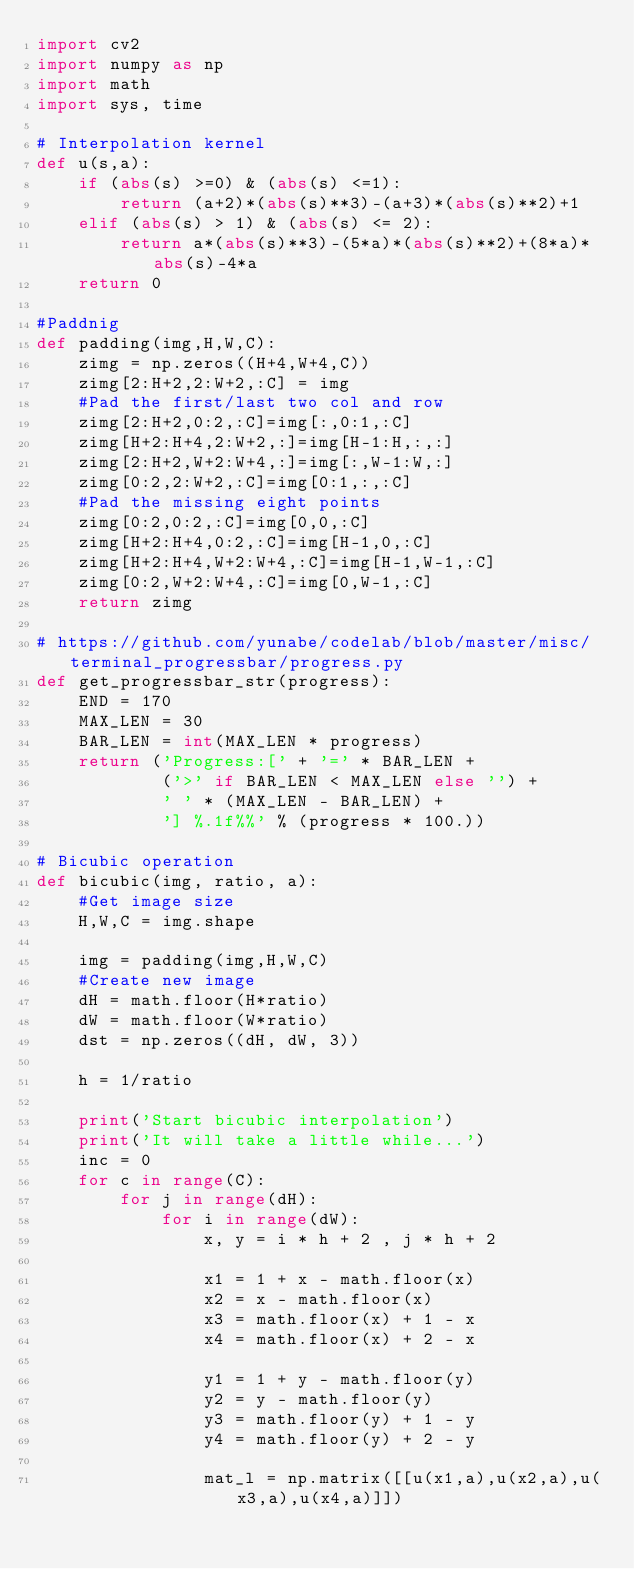Convert code to text. <code><loc_0><loc_0><loc_500><loc_500><_Python_>import cv2
import numpy as np
import math
import sys, time

# Interpolation kernel
def u(s,a):
    if (abs(s) >=0) & (abs(s) <=1):
        return (a+2)*(abs(s)**3)-(a+3)*(abs(s)**2)+1
    elif (abs(s) > 1) & (abs(s) <= 2):
        return a*(abs(s)**3)-(5*a)*(abs(s)**2)+(8*a)*abs(s)-4*a
    return 0

#Paddnig
def padding(img,H,W,C):
    zimg = np.zeros((H+4,W+4,C))
    zimg[2:H+2,2:W+2,:C] = img
    #Pad the first/last two col and row
    zimg[2:H+2,0:2,:C]=img[:,0:1,:C]
    zimg[H+2:H+4,2:W+2,:]=img[H-1:H,:,:]
    zimg[2:H+2,W+2:W+4,:]=img[:,W-1:W,:]
    zimg[0:2,2:W+2,:C]=img[0:1,:,:C]
    #Pad the missing eight points
    zimg[0:2,0:2,:C]=img[0,0,:C]
    zimg[H+2:H+4,0:2,:C]=img[H-1,0,:C]
    zimg[H+2:H+4,W+2:W+4,:C]=img[H-1,W-1,:C]
    zimg[0:2,W+2:W+4,:C]=img[0,W-1,:C]
    return zimg

# https://github.com/yunabe/codelab/blob/master/misc/terminal_progressbar/progress.py
def get_progressbar_str(progress):
    END = 170
    MAX_LEN = 30
    BAR_LEN = int(MAX_LEN * progress)
    return ('Progress:[' + '=' * BAR_LEN +
            ('>' if BAR_LEN < MAX_LEN else '') +
            ' ' * (MAX_LEN - BAR_LEN) +
            '] %.1f%%' % (progress * 100.))

# Bicubic operation
def bicubic(img, ratio, a):
    #Get image size
    H,W,C = img.shape

    img = padding(img,H,W,C)
    #Create new image
    dH = math.floor(H*ratio)
    dW = math.floor(W*ratio)
    dst = np.zeros((dH, dW, 3))

    h = 1/ratio

    print('Start bicubic interpolation')
    print('It will take a little while...')
    inc = 0
    for c in range(C):
        for j in range(dH):
            for i in range(dW):
                x, y = i * h + 2 , j * h + 2

                x1 = 1 + x - math.floor(x)
                x2 = x - math.floor(x)
                x3 = math.floor(x) + 1 - x
                x4 = math.floor(x) + 2 - x

                y1 = 1 + y - math.floor(y)
                y2 = y - math.floor(y)
                y3 = math.floor(y) + 1 - y
                y4 = math.floor(y) + 2 - y

                mat_l = np.matrix([[u(x1,a),u(x2,a),u(x3,a),u(x4,a)]])</code> 